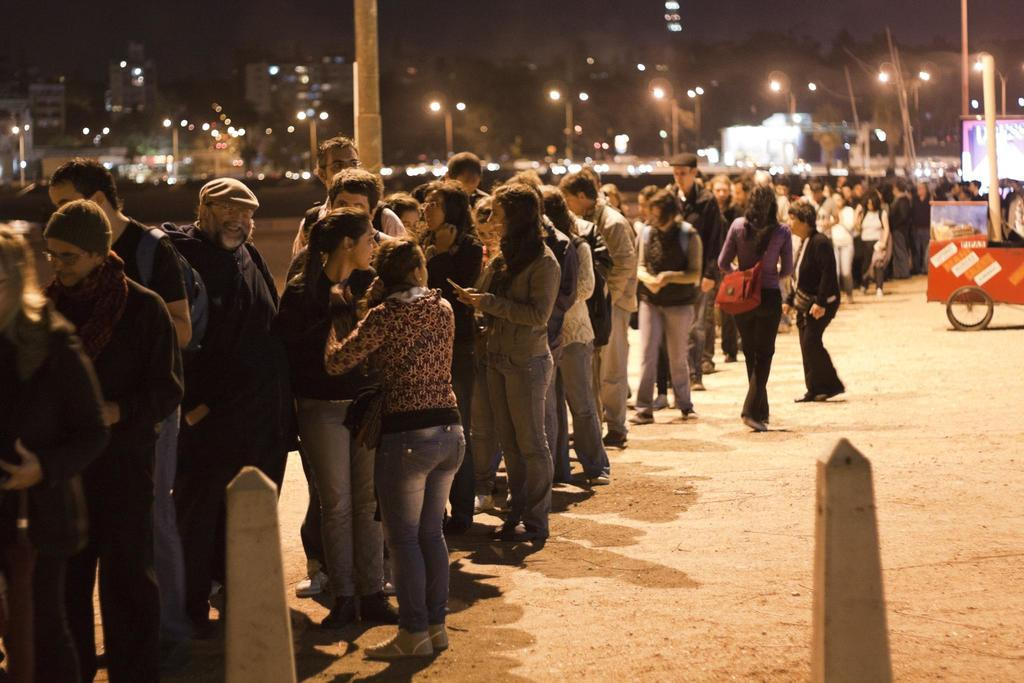How many people are in the group visible in the image? There is a group of people in the image, but the exact number cannot be determined from the provided facts. What type of vehicle is present in the image? There is a vehicle in the image, but its specific type cannot be determined from the provided facts. What can be seen in the background of the image? There are buildings and light poles in the background of the image. What is the color of the sky in the image? The sky is white in color in the image. Can you see the toothbrush that the person is using in the image? There is no toothbrush visible in the image. How many toes are visible on the person's feet in the image? There is no person's feet visible in the image, so it is impossible to determine the number of toes. 